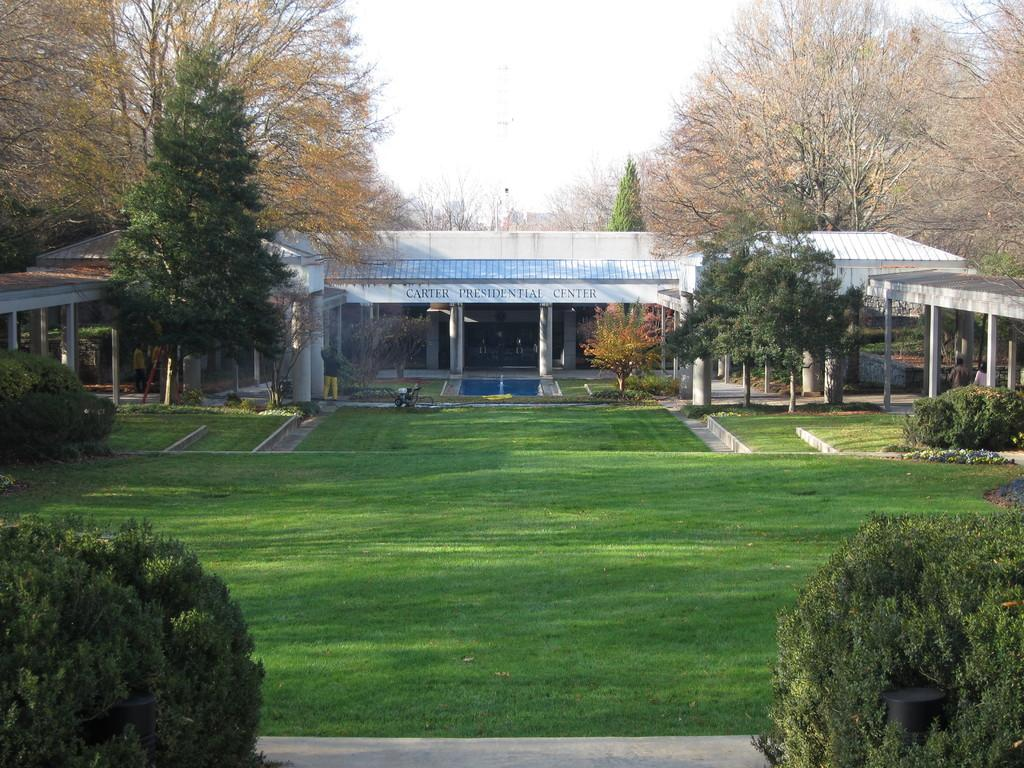What is being constructed in the image? There is a shed construction in the image. What is attached to the shed? There is a poster on the shed. What can be read on the poster? There is text on the poster. What type of vegetation is visible in the image? There is grass, plants, and trees visible in the image. What part of the natural environment is visible in the image? The sky is visible in the image. How many trucks are parked near the shed in the image? There are no trucks visible in the image; it only shows a shed construction with a poster and text. Can you tell me how many times the person in the image sneezes? There is no person present in the image, so it is impossible to determine if anyone sneezes. 